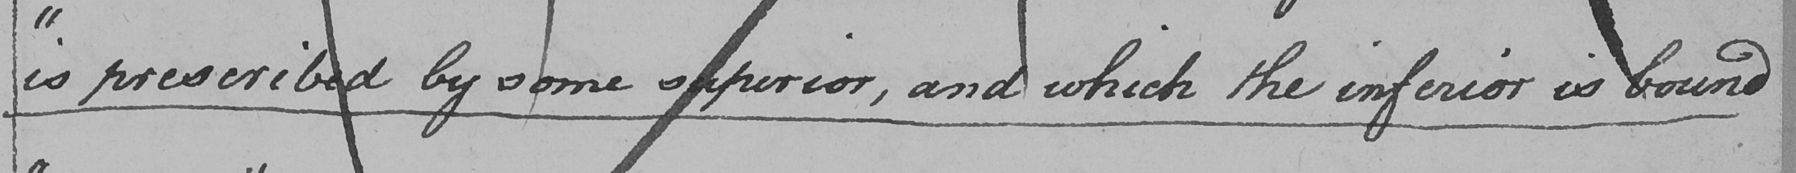Transcribe the text shown in this historical manuscript line. " is prescribed by some superior , and which the inferior is bound 